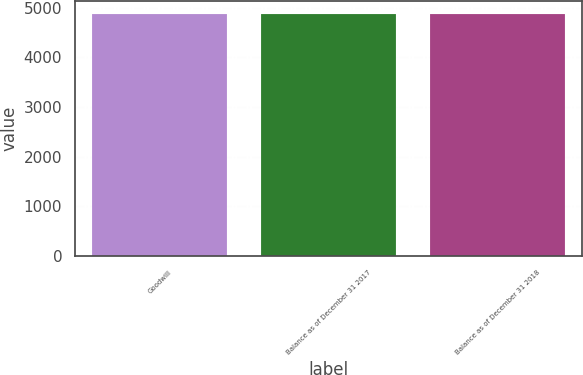<chart> <loc_0><loc_0><loc_500><loc_500><bar_chart><fcel>Goodwill<fcel>Balance as of December 31 2017<fcel>Balance as of December 31 2018<nl><fcel>4883<fcel>4883.1<fcel>4883.2<nl></chart> 